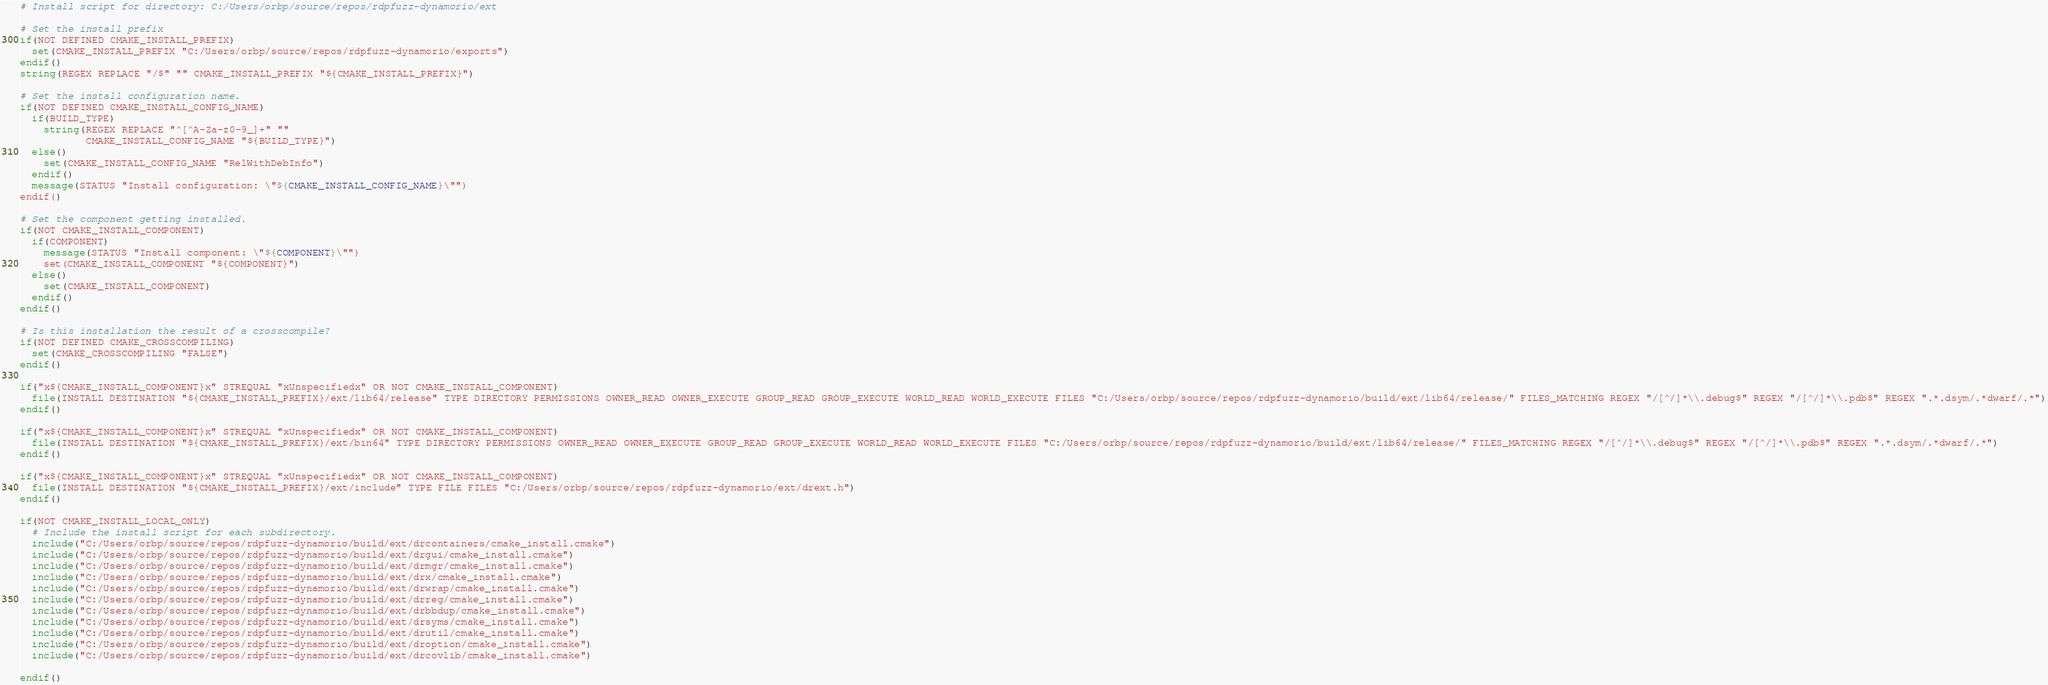<code> <loc_0><loc_0><loc_500><loc_500><_CMake_># Install script for directory: C:/Users/orbp/source/repos/rdpfuzz-dynamorio/ext

# Set the install prefix
if(NOT DEFINED CMAKE_INSTALL_PREFIX)
  set(CMAKE_INSTALL_PREFIX "C:/Users/orbp/source/repos/rdpfuzz-dynamorio/exports")
endif()
string(REGEX REPLACE "/$" "" CMAKE_INSTALL_PREFIX "${CMAKE_INSTALL_PREFIX}")

# Set the install configuration name.
if(NOT DEFINED CMAKE_INSTALL_CONFIG_NAME)
  if(BUILD_TYPE)
    string(REGEX REPLACE "^[^A-Za-z0-9_]+" ""
           CMAKE_INSTALL_CONFIG_NAME "${BUILD_TYPE}")
  else()
    set(CMAKE_INSTALL_CONFIG_NAME "RelWithDebInfo")
  endif()
  message(STATUS "Install configuration: \"${CMAKE_INSTALL_CONFIG_NAME}\"")
endif()

# Set the component getting installed.
if(NOT CMAKE_INSTALL_COMPONENT)
  if(COMPONENT)
    message(STATUS "Install component: \"${COMPONENT}\"")
    set(CMAKE_INSTALL_COMPONENT "${COMPONENT}")
  else()
    set(CMAKE_INSTALL_COMPONENT)
  endif()
endif()

# Is this installation the result of a crosscompile?
if(NOT DEFINED CMAKE_CROSSCOMPILING)
  set(CMAKE_CROSSCOMPILING "FALSE")
endif()

if("x${CMAKE_INSTALL_COMPONENT}x" STREQUAL "xUnspecifiedx" OR NOT CMAKE_INSTALL_COMPONENT)
  file(INSTALL DESTINATION "${CMAKE_INSTALL_PREFIX}/ext/lib64/release" TYPE DIRECTORY PERMISSIONS OWNER_READ OWNER_EXECUTE GROUP_READ GROUP_EXECUTE WORLD_READ WORLD_EXECUTE FILES "C:/Users/orbp/source/repos/rdpfuzz-dynamorio/build/ext/lib64/release/" FILES_MATCHING REGEX "/[^/]*\\.debug$" REGEX "/[^/]*\\.pdb$" REGEX ".*.dsym/.*dwarf/.*")
endif()

if("x${CMAKE_INSTALL_COMPONENT}x" STREQUAL "xUnspecifiedx" OR NOT CMAKE_INSTALL_COMPONENT)
  file(INSTALL DESTINATION "${CMAKE_INSTALL_PREFIX}/ext/bin64" TYPE DIRECTORY PERMISSIONS OWNER_READ OWNER_EXECUTE GROUP_READ GROUP_EXECUTE WORLD_READ WORLD_EXECUTE FILES "C:/Users/orbp/source/repos/rdpfuzz-dynamorio/build/ext/lib64/release/" FILES_MATCHING REGEX "/[^/]*\\.debug$" REGEX "/[^/]*\\.pdb$" REGEX ".*.dsym/.*dwarf/.*")
endif()

if("x${CMAKE_INSTALL_COMPONENT}x" STREQUAL "xUnspecifiedx" OR NOT CMAKE_INSTALL_COMPONENT)
  file(INSTALL DESTINATION "${CMAKE_INSTALL_PREFIX}/ext/include" TYPE FILE FILES "C:/Users/orbp/source/repos/rdpfuzz-dynamorio/ext/drext.h")
endif()

if(NOT CMAKE_INSTALL_LOCAL_ONLY)
  # Include the install script for each subdirectory.
  include("C:/Users/orbp/source/repos/rdpfuzz-dynamorio/build/ext/drcontainers/cmake_install.cmake")
  include("C:/Users/orbp/source/repos/rdpfuzz-dynamorio/build/ext/drgui/cmake_install.cmake")
  include("C:/Users/orbp/source/repos/rdpfuzz-dynamorio/build/ext/drmgr/cmake_install.cmake")
  include("C:/Users/orbp/source/repos/rdpfuzz-dynamorio/build/ext/drx/cmake_install.cmake")
  include("C:/Users/orbp/source/repos/rdpfuzz-dynamorio/build/ext/drwrap/cmake_install.cmake")
  include("C:/Users/orbp/source/repos/rdpfuzz-dynamorio/build/ext/drreg/cmake_install.cmake")
  include("C:/Users/orbp/source/repos/rdpfuzz-dynamorio/build/ext/drbbdup/cmake_install.cmake")
  include("C:/Users/orbp/source/repos/rdpfuzz-dynamorio/build/ext/drsyms/cmake_install.cmake")
  include("C:/Users/orbp/source/repos/rdpfuzz-dynamorio/build/ext/drutil/cmake_install.cmake")
  include("C:/Users/orbp/source/repos/rdpfuzz-dynamorio/build/ext/droption/cmake_install.cmake")
  include("C:/Users/orbp/source/repos/rdpfuzz-dynamorio/build/ext/drcovlib/cmake_install.cmake")

endif()

</code> 